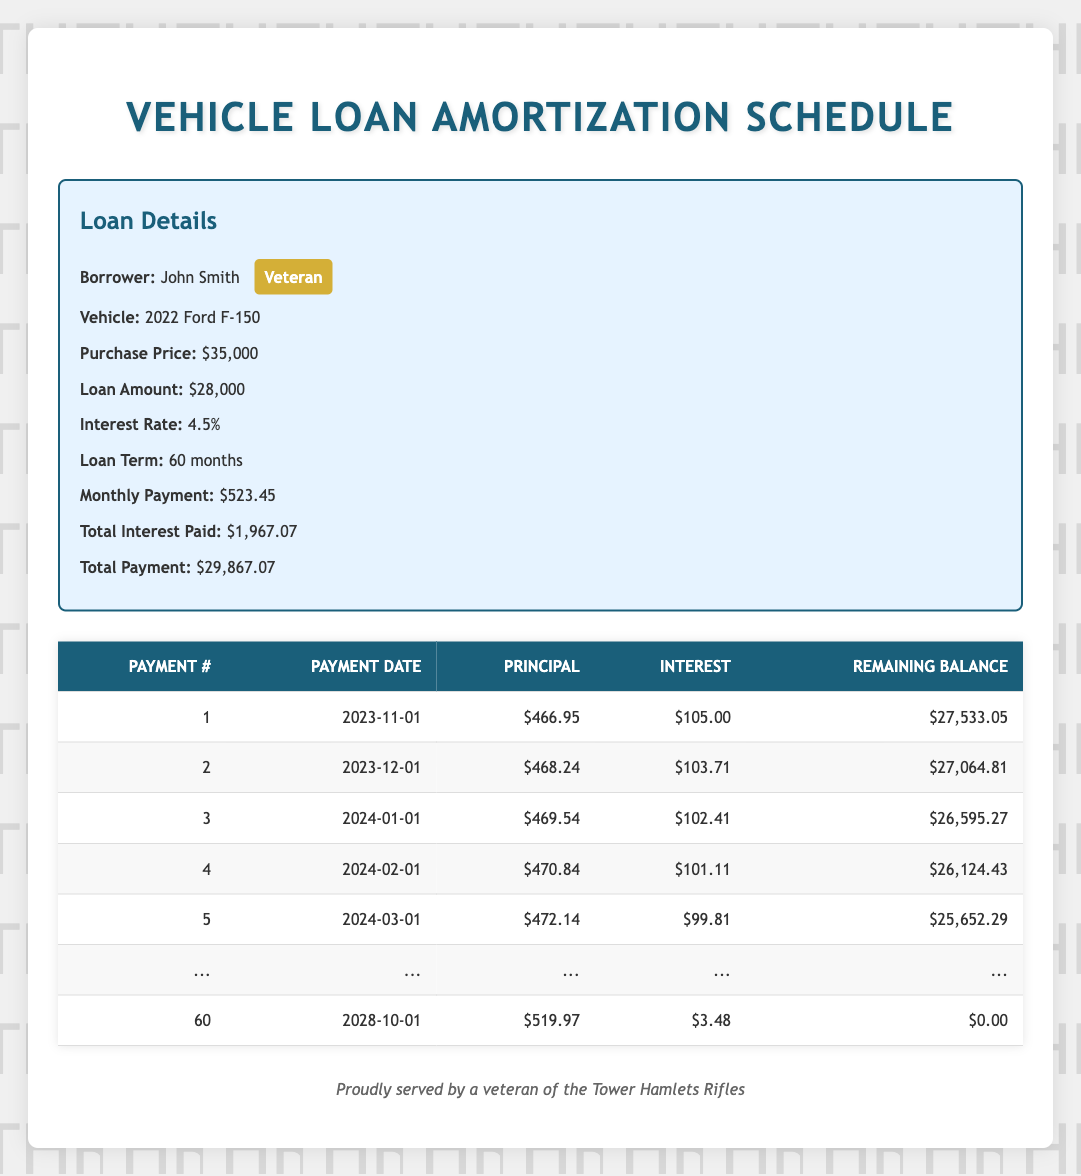What is the monthly payment for John Smith's vehicle loan? The monthly payment is explicitly stated in the loan details section of the table, listed as $523.45.
Answer: 523.45 What was the total interest paid over the course of the loan? The total interest paid can be found under the loan details and is provided as $1,967.07.
Answer: 1967.07 How much principal is paid in the first payment? The principal paid in the first payment is listed in the amortization schedule under the principal payment column for payment number 1, which is $466.95.
Answer: 466.95 Is the interest payment for the last payment higher than for the first payment? The interest payment for the first payment is $105.00, while the last payment's interest payment is $3.48. Since $105.00 is greater than $3.48, the statement is true.
Answer: Yes What is the remaining balance after the second payment? The remaining balance is shown in the amortization schedule for payment number 2, which is $27,064.81.
Answer: 27064.81 Calculate the total principal payment made after the first five payments. The total principal payment for the first five payments is the sum of the principal payments: 466.95 + 468.24 + 469.54 + 470.84 + 472.14 = 2347.71.
Answer: 2347.71 How many months are left on the loan after the third payment? The loan term is 60 months, and after the third payment, 3 payments have been made, so 60 - 3 = 57 months are left.
Answer: 57 What is the difference in the principal payment between the first payment and the last payment? The principal payment for the first payment is $466.95, and the last payment's principal payment is $519.97. The difference is $519.97 - $466.95 = $53.02.
Answer: 53.02 What is the total amount paid by the end of the loan term? The total payment over the course of the loan is stated in the loan details as $29,867.07.
Answer: 29867.07 